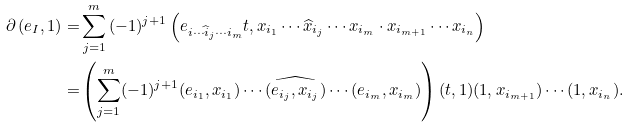<formula> <loc_0><loc_0><loc_500><loc_500>\partial \left ( e _ { I } , 1 \right ) = & \sum _ { j = 1 } ^ { m } { ( - 1 ) ^ { j + 1 } \left ( e _ { i \cdots \widehat { i } _ { j } \cdots i _ { m } } t , x _ { i _ { 1 } } \cdots \widehat { x } _ { i _ { j } } \cdots x _ { i _ { m } } \cdot x _ { i _ { m + 1 } } \cdots x _ { i _ { n } } \right ) } \\ = & \left ( \sum _ { j = 1 } ^ { m } ( - 1 ) ^ { j + 1 } ( e _ { i _ { 1 } } , x _ { i _ { 1 } } ) \cdots \widehat { ( e _ { i _ { j } } , x _ { i _ { j } } ) } \cdots ( e _ { i _ { m } } , x _ { i _ { m } } ) \right ) ( t , 1 ) ( 1 , x _ { i _ { m + 1 } } ) \cdots ( 1 , x _ { i _ { n } } ) .</formula> 